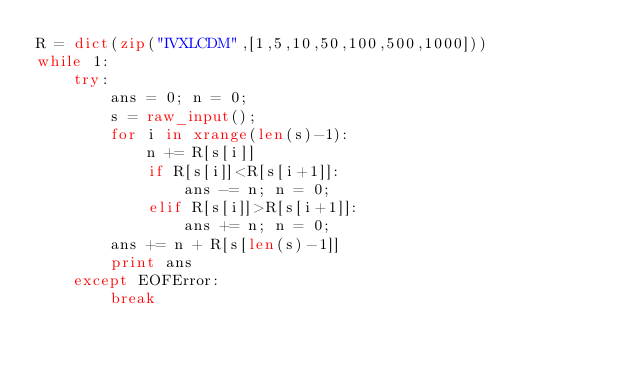<code> <loc_0><loc_0><loc_500><loc_500><_Python_>R = dict(zip("IVXLCDM",[1,5,10,50,100,500,1000]))
while 1:
    try:
        ans = 0; n = 0;
        s = raw_input();
        for i in xrange(len(s)-1):
            n += R[s[i]]
            if R[s[i]]<R[s[i+1]]:
                ans -= n; n = 0;
            elif R[s[i]]>R[s[i+1]]:
                ans += n; n = 0;
        ans += n + R[s[len(s)-1]]
        print ans
    except EOFError:
        break</code> 